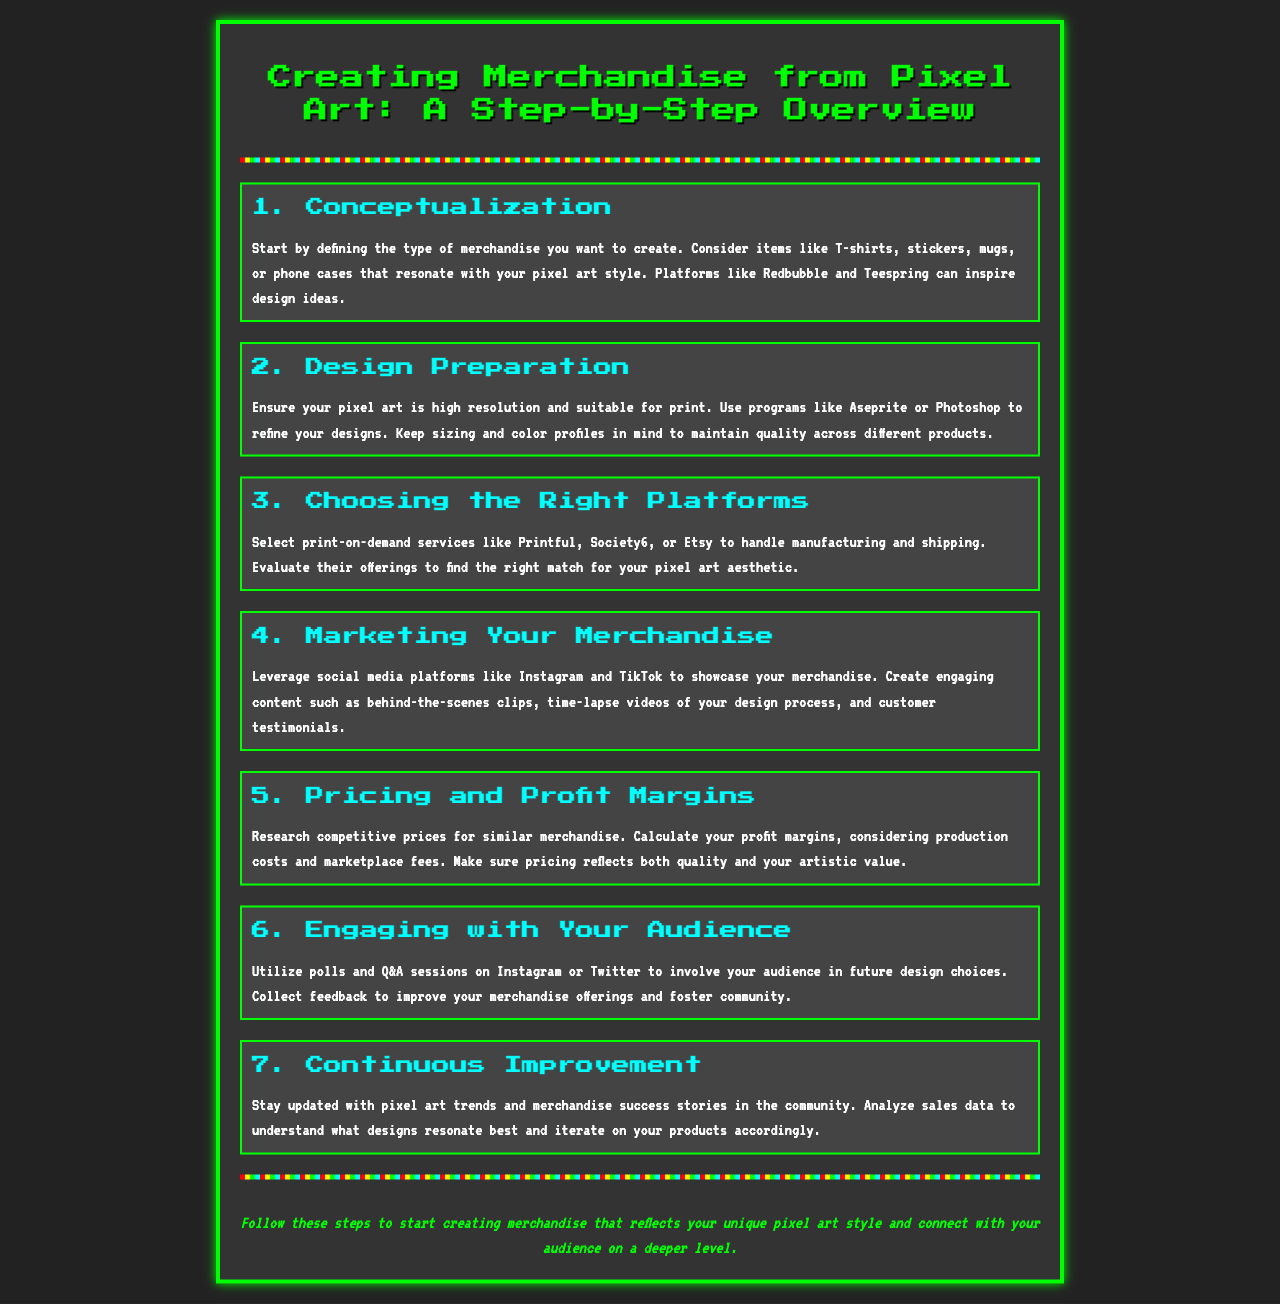What is the first step in creating merchandise from pixel art? The first step listed in the document is "Conceptualization," which involves defining the type of merchandise to create.
Answer: Conceptualization Which program is suggested for refining pixel art designs? The document mentions Aseprite and Photoshop as programs suitable for refining designs.
Answer: Aseprite or Photoshop What type of products can be created from pixel art according to the document? The document lists items like T-shirts, stickers, mugs, or phone cases as potential products.
Answer: T-shirts, stickers, mugs, or phone cases Which platforms are recommended for marketing merchandise? The text suggests using social media platforms like Instagram and TikTok for marketing purposes.
Answer: Instagram and TikTok What is an essential factor to consider when pricing merchandise? The document emphasizes calculating profit margins while considering production costs and marketplace fees as essential factors.
Answer: Profit margins What is the seventh step in the overview? The seventh step outlined in the document is "Continuous Improvement," focusing on staying updated with trends and analyzing sales data.
Answer: Continuous Improvement How should an artist engage with their audience? The document suggests utilizing polls and Q&A sessions on Instagram or Twitter to involve the audience.
Answer: Polls and Q&A sessions What color is the title text in the document? The title text is colored green, as indicated in the document styling.
Answer: Green 